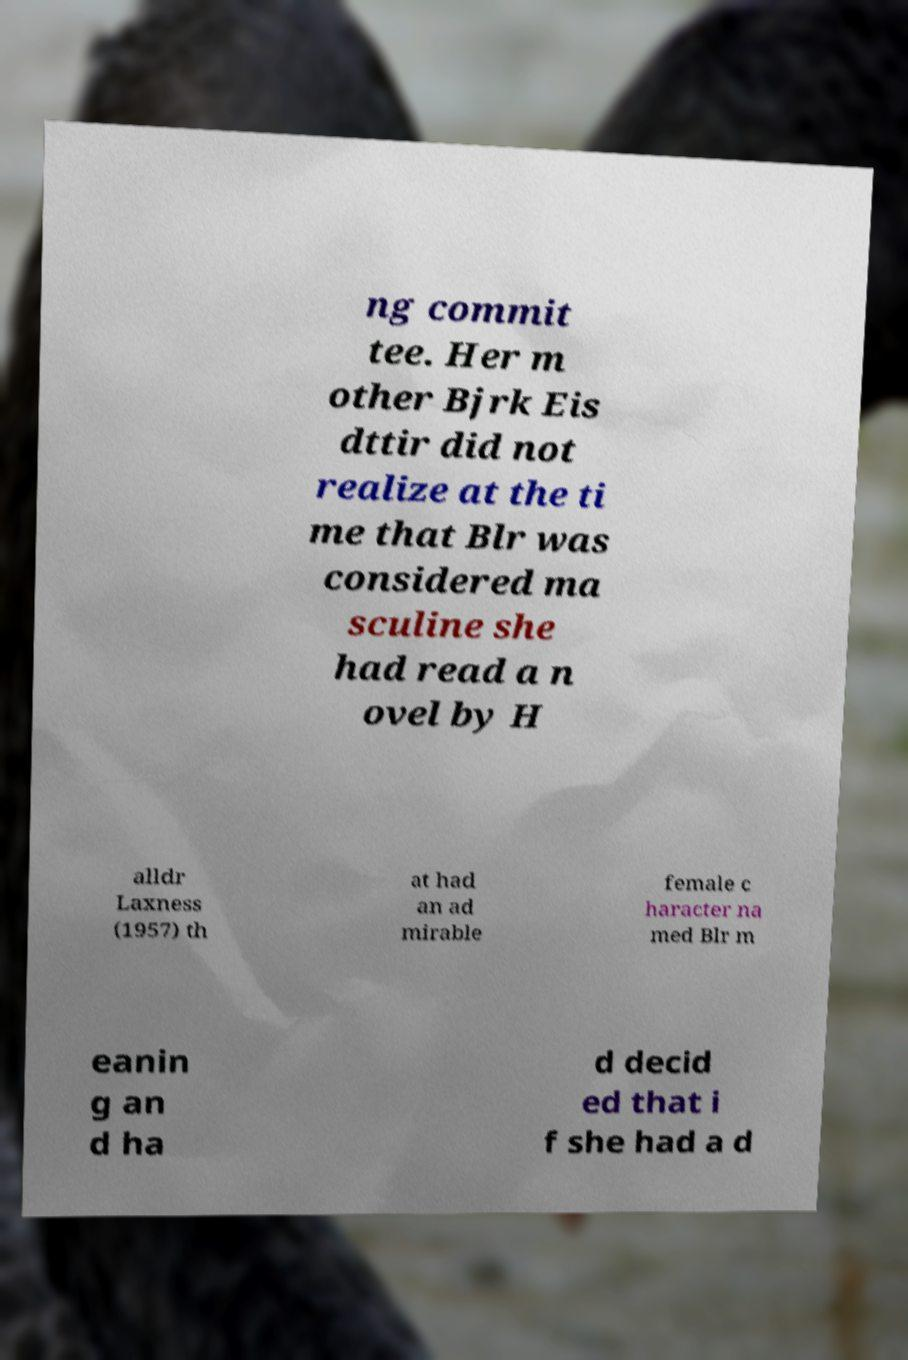What messages or text are displayed in this image? I need them in a readable, typed format. ng commit tee. Her m other Bjrk Eis dttir did not realize at the ti me that Blr was considered ma sculine she had read a n ovel by H alldr Laxness (1957) th at had an ad mirable female c haracter na med Blr m eanin g an d ha d decid ed that i f she had a d 